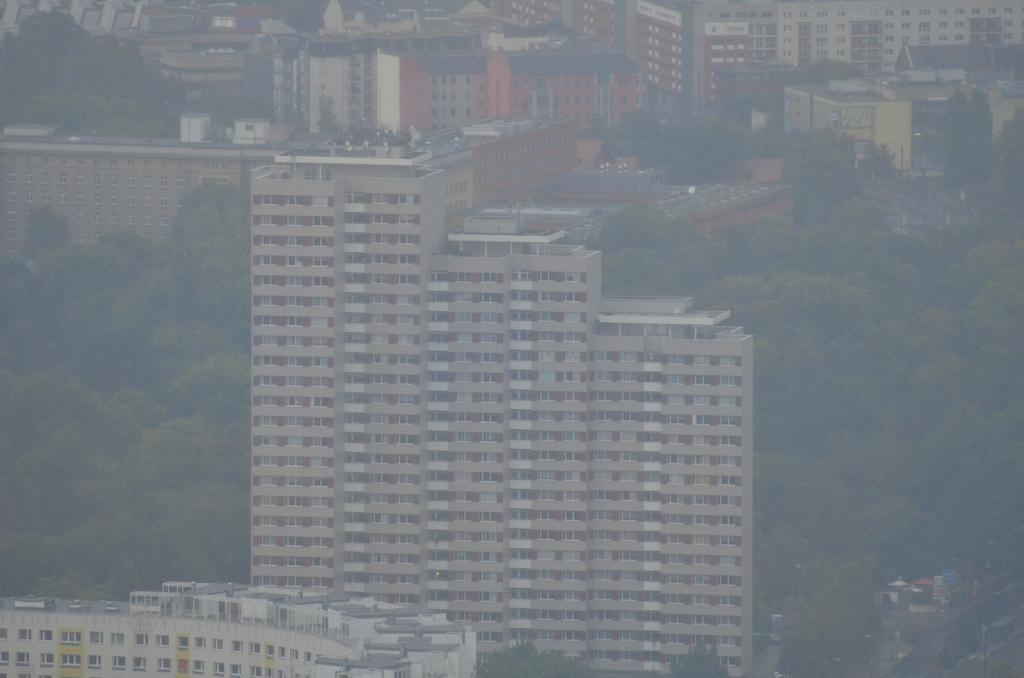What type of structures can be seen in the image? There are buildings in the image. What other natural elements are present in the image? There are trees in the image. What can be seen beneath the buildings and trees? The ground is visible in the image. Can you describe the objects located in the bottom right corner of the corner of the image? Unfortunately, the provided facts do not give any information about the objects in the bottom right corner of the image. What type of club is playing the songs in the image? There is no club or songs mentioned in the image; it only features buildings, trees, and the ground. 